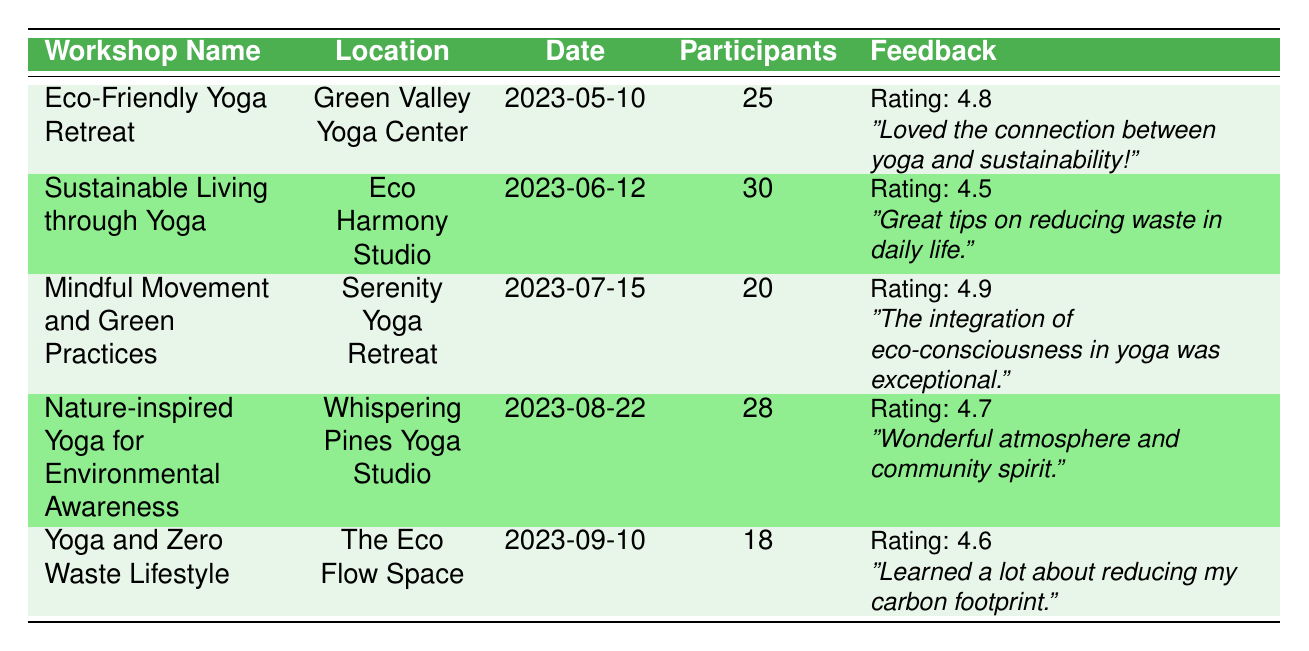What is the satisfaction rating for the "Sustainable Living through Yoga" workshop? The satisfaction rating is specifically listed under the feedback section for the "Sustainable Living through Yoga" workshop. It states that the rating is 4.5.
Answer: 4.5 How many participants attended the "Eco-Friendly Yoga Retreat"? The number of participants for the "Eco-Friendly Yoga Retreat" is mentioned directly in the table, stating that there were 25 participants.
Answer: 25 What is the total number of participants across all workshops? To find the total number of participants, we sum the participants from each workshop: 25 + 30 + 20 + 28 + 18 = 121. Thus, the total number of participants across the workshops is 121.
Answer: 121 Was the satisfaction rating for "Mindful Movement and Green Practices" higher than 4.7? The satisfaction rating for "Mindful Movement and Green Practices" is 4.9, which is indeed higher than 4.7. Therefore, the answer is yes.
Answer: Yes What are the average satisfaction ratings of the workshops? To calculate the average satisfaction rating, we add all ratings and divide by the total number of workshops: (4.8 + 4.5 + 4.9 + 4.7 + 4.6) = 24.5, then divide by 5, which equals 4.9.
Answer: 4.9 Which workshop had the highest number of participants? By comparing the participant numbers across all workshops, the "Sustainable Living through Yoga" workshop had the highest number with 30 participants.
Answer: Sustainable Living through Yoga Is there a comment from any workshop mentioning "solar energy"? In the feedback for the "Eco-Friendly Yoga Retreat," there is a comment that mentions "The solar energy presentation was inspiring," confirming that such a comment exists.
Answer: Yes Did the "Yoga and Zero Waste Lifestyle" workshop receive a satisfaction rating lower than 4.5? The satisfaction rating for the "Yoga and Zero Waste Lifestyle" workshop is 4.6, which is above 4.5. Therefore, the answer is no.
Answer: No Which workshop had the least number of participants and what was the rating? "Yoga and Zero Waste Lifestyle" had the least number of participants, with a count of 18 and a satisfaction rating of 4.6. The answer combines both participant and rating information to provide a complete response.
Answer: Yoga and Zero Waste Lifestyle, 4.6 